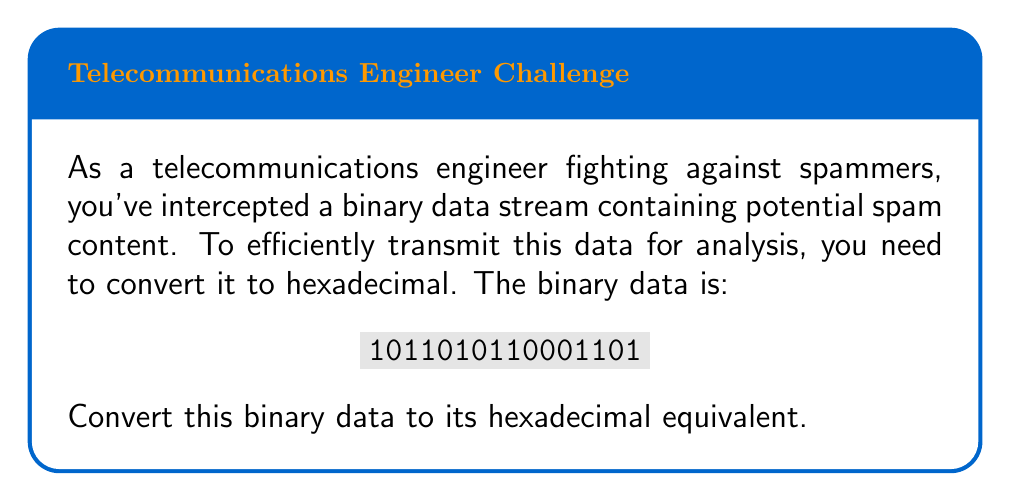Could you help me with this problem? To convert binary to hexadecimal, we'll follow these steps:

1) Group the binary digits into sets of 4, starting from the right:
   $$1011\;0101\;1000\;1101$$

2) Convert each group of 4 binary digits to its hexadecimal equivalent:

   - $1101_2 = 13_{10} = \text{D}_{16}$
   - $1000_2 = 8_{10} = 8_{16}$
   - $0101_2 = 5_{10} = 5_{16}$
   - $1011_2 = 11_{10} = \text{B}_{16}$

3) Concatenate the hexadecimal digits:

   $$\text{B}5\text{8D}_{16}$$

This conversion reduces the data length from 16 binary digits to 4 hexadecimal digits, making transmission more efficient.
Answer: $\text{B}5\text{8D}_{16}$ 